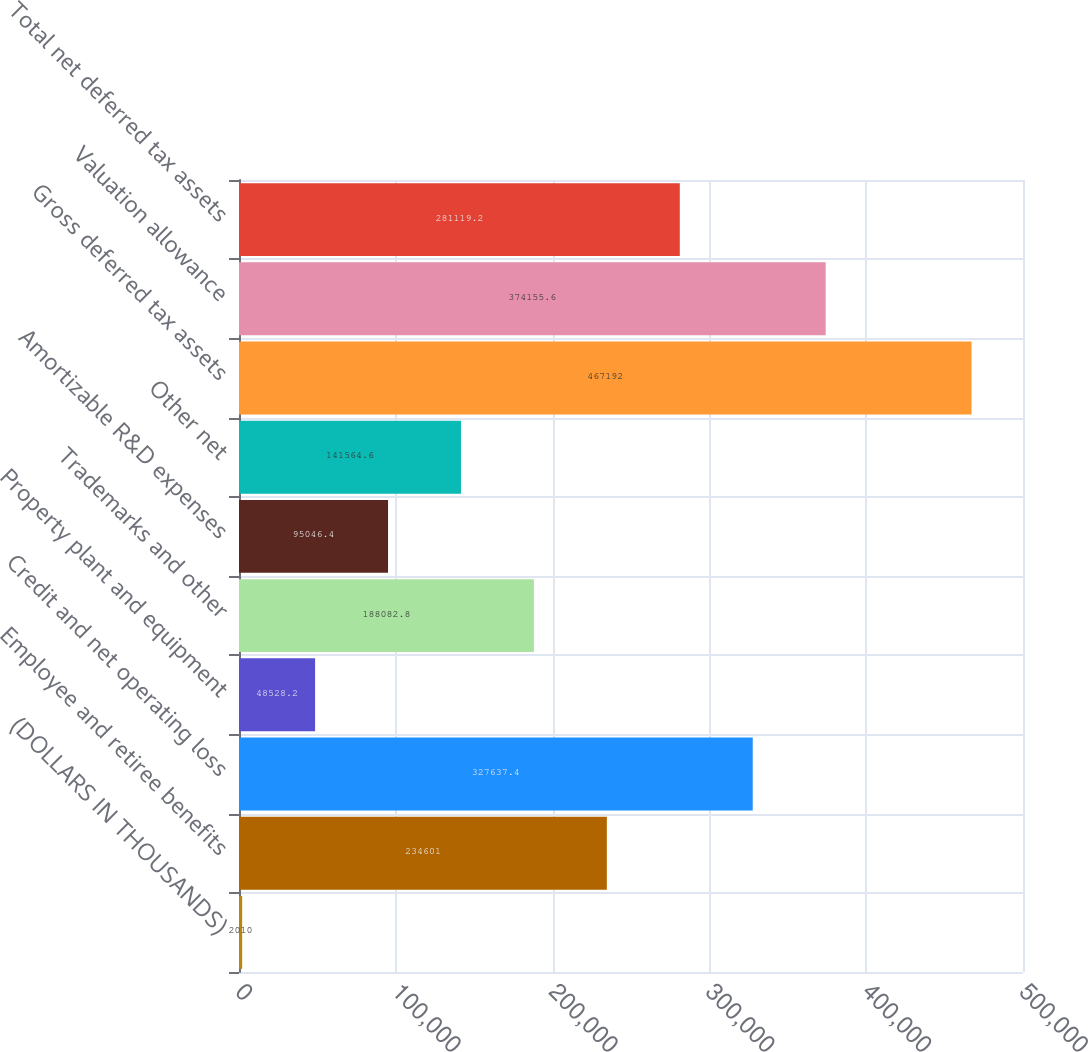<chart> <loc_0><loc_0><loc_500><loc_500><bar_chart><fcel>(DOLLARS IN THOUSANDS)<fcel>Employee and retiree benefits<fcel>Credit and net operating loss<fcel>Property plant and equipment<fcel>Trademarks and other<fcel>Amortizable R&D expenses<fcel>Other net<fcel>Gross deferred tax assets<fcel>Valuation allowance<fcel>Total net deferred tax assets<nl><fcel>2010<fcel>234601<fcel>327637<fcel>48528.2<fcel>188083<fcel>95046.4<fcel>141565<fcel>467192<fcel>374156<fcel>281119<nl></chart> 